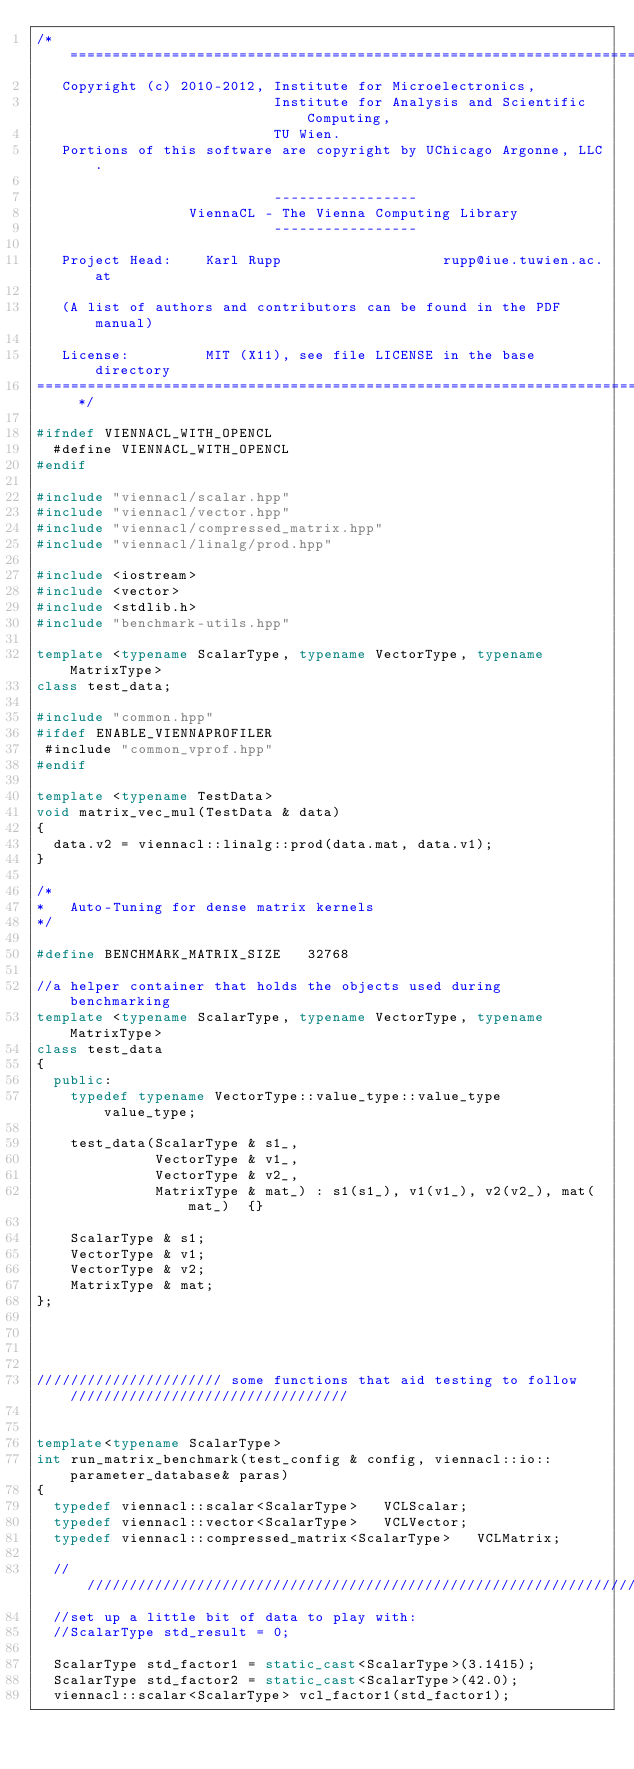Convert code to text. <code><loc_0><loc_0><loc_500><loc_500><_C++_>/* =========================================================================
   Copyright (c) 2010-2012, Institute for Microelectronics,
                            Institute for Analysis and Scientific Computing,
                            TU Wien.
   Portions of this software are copyright by UChicago Argonne, LLC.

                            -----------------
                  ViennaCL - The Vienna Computing Library
                            -----------------

   Project Head:    Karl Rupp                   rupp@iue.tuwien.ac.at
               
   (A list of authors and contributors can be found in the PDF manual)

   License:         MIT (X11), see file LICENSE in the base directory
============================================================================= */

#ifndef VIENNACL_WITH_OPENCL
  #define VIENNACL_WITH_OPENCL
#endif

#include "viennacl/scalar.hpp"
#include "viennacl/vector.hpp"
#include "viennacl/compressed_matrix.hpp"
#include "viennacl/linalg/prod.hpp"

#include <iostream>
#include <vector>
#include <stdlib.h>
#include "benchmark-utils.hpp"

template <typename ScalarType, typename VectorType, typename MatrixType>
class test_data;

#include "common.hpp"
#ifdef ENABLE_VIENNAPROFILER
 #include "common_vprof.hpp"
#endif

template <typename TestData>
void matrix_vec_mul(TestData & data)
{
  data.v2 = viennacl::linalg::prod(data.mat, data.v1);
}

/*
*   Auto-Tuning for dense matrix kernels
*/

#define BENCHMARK_MATRIX_SIZE   32768

//a helper container that holds the objects used during benchmarking
template <typename ScalarType, typename VectorType, typename MatrixType>
class test_data
{
  public:
    typedef typename VectorType::value_type::value_type   value_type;
    
    test_data(ScalarType & s1_,
              VectorType & v1_,
              VectorType & v2_,
              MatrixType & mat_) : s1(s1_), v1(v1_), v2(v2_), mat(mat_)  {}
    
    ScalarType & s1;
    VectorType & v1;
    VectorType & v2;
    MatrixType & mat;
};




////////////////////// some functions that aid testing to follow /////////////////////////////////


template<typename ScalarType>
int run_matrix_benchmark(test_config & config, viennacl::io::parameter_database& paras)
{
  typedef viennacl::scalar<ScalarType>   VCLScalar;
  typedef viennacl::vector<ScalarType>   VCLVector;
  typedef viennacl::compressed_matrix<ScalarType>   VCLMatrix;
   
  ////////////////////////////////////////////////////////////////////
  //set up a little bit of data to play with:
  //ScalarType std_result = 0;
   
  ScalarType std_factor1 = static_cast<ScalarType>(3.1415);
  ScalarType std_factor2 = static_cast<ScalarType>(42.0);
  viennacl::scalar<ScalarType> vcl_factor1(std_factor1);</code> 